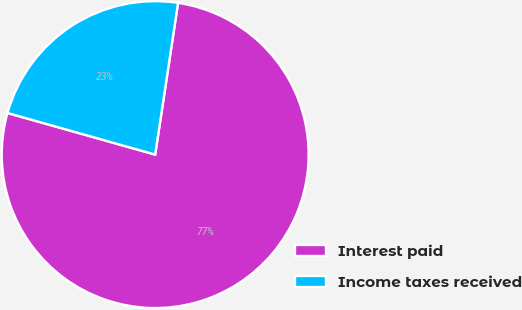<chart> <loc_0><loc_0><loc_500><loc_500><pie_chart><fcel>Interest paid<fcel>Income taxes received<nl><fcel>76.99%<fcel>23.01%<nl></chart> 